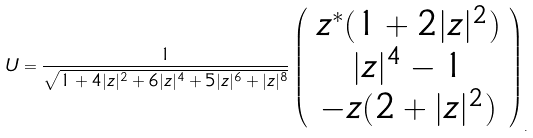<formula> <loc_0><loc_0><loc_500><loc_500>U = \frac { 1 } { \sqrt { 1 + 4 | z | ^ { 2 } + 6 | z | ^ { 4 } + 5 | z | ^ { 6 } + | z | ^ { 8 } } } \left ( \begin{array} { c } z ^ { * } ( 1 + 2 | z | ^ { 2 } ) \\ | z | ^ { 4 } - 1 \\ - z ( 2 + | z | ^ { 2 } ) \end{array} \right ) _ { . }</formula> 